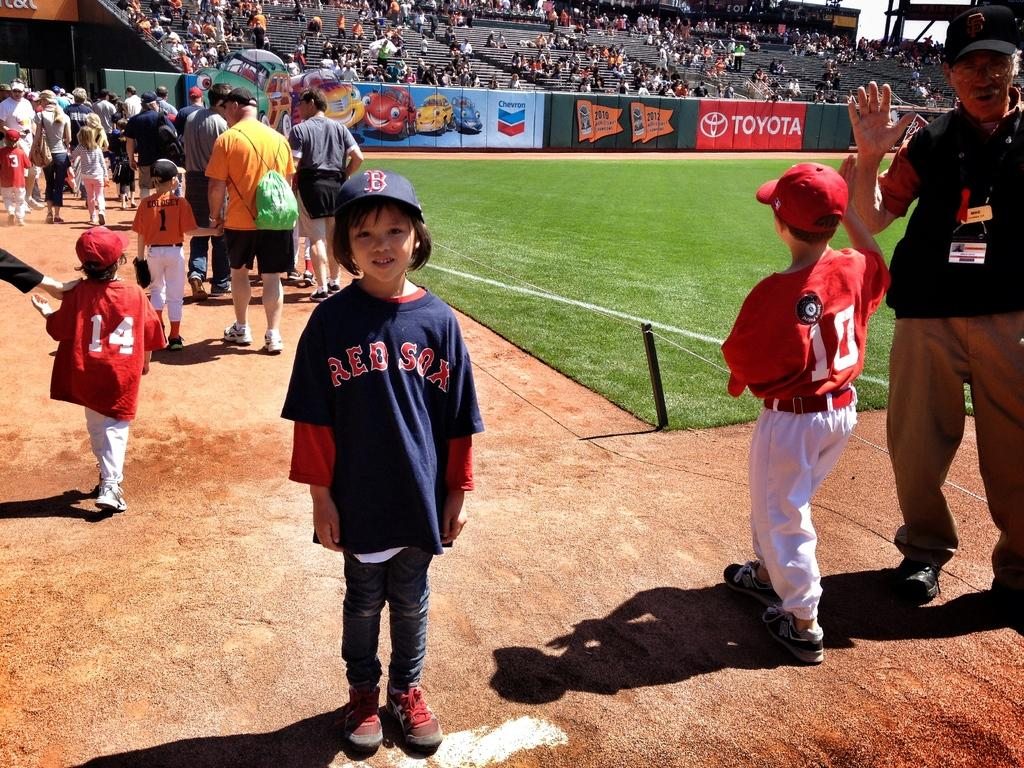<image>
Provide a brief description of the given image. Baseball player wearing a jersey that says Red Sox. 